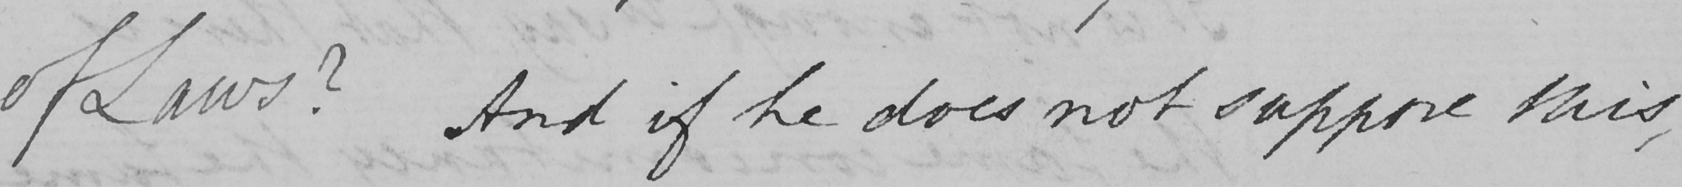Can you tell me what this handwritten text says? of Laws ?  And if he does not suppose this , 